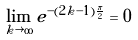Convert formula to latex. <formula><loc_0><loc_0><loc_500><loc_500>\lim _ { k \rightarrow \infty } e ^ { - ( 2 k - 1 ) \frac { \pi } { 2 } } = 0</formula> 